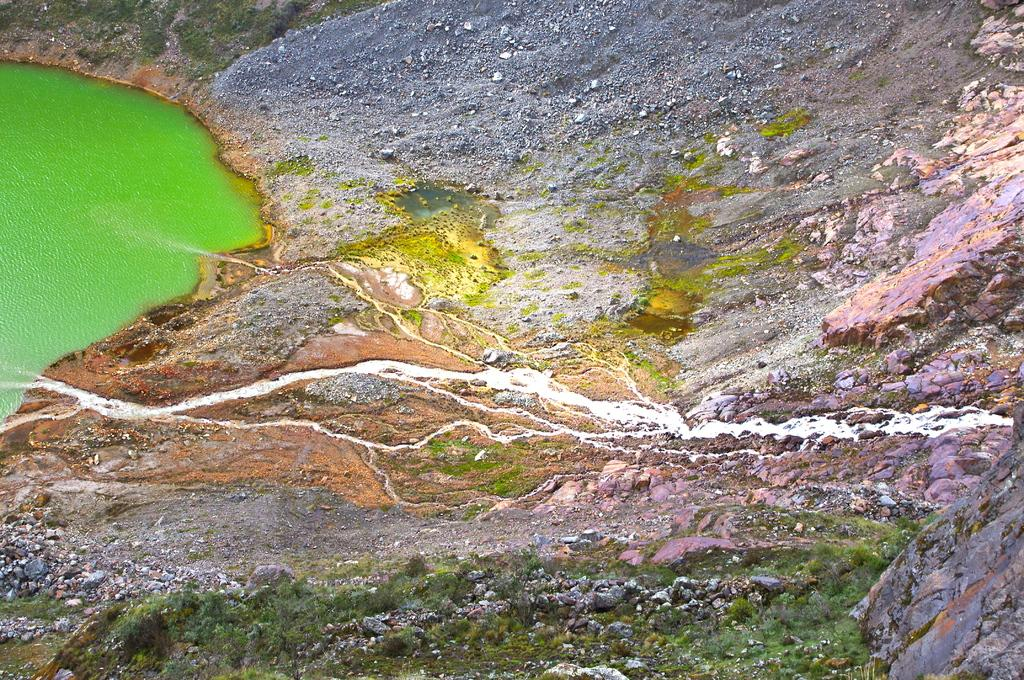What is visible in the image? Water and rocks are visible in the image. Can you describe the water in the image? The water is visible in the image. What other objects or features can be seen in the image? Rocks are present in the image. How many apples are floating on the water in the image? There are no apples present in the image. Can you tell me how the rocks are pushing the water in the image? The rocks are not pushing the water in the image; they are stationary. 